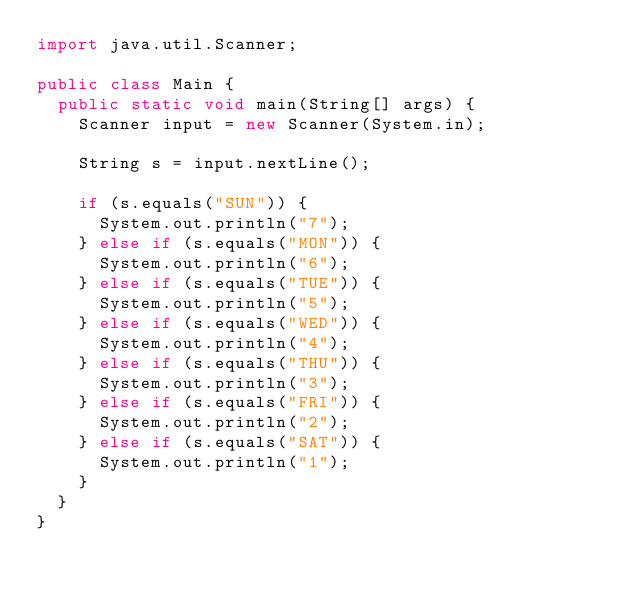<code> <loc_0><loc_0><loc_500><loc_500><_Java_>import java.util.Scanner;

public class Main {
  public static void main(String[] args) {
    Scanner input = new Scanner(System.in);

    String s = input.nextLine();

    if (s.equals("SUN")) {
      System.out.println("7");
    } else if (s.equals("MON")) {
      System.out.println("6");
    } else if (s.equals("TUE")) {
      System.out.println("5");
    } else if (s.equals("WED")) {
      System.out.println("4");
    } else if (s.equals("THU")) {
      System.out.println("3");
    } else if (s.equals("FRI")) {
      System.out.println("2");
    } else if (s.equals("SAT")) {
      System.out.println("1");
    }
  }
}
</code> 